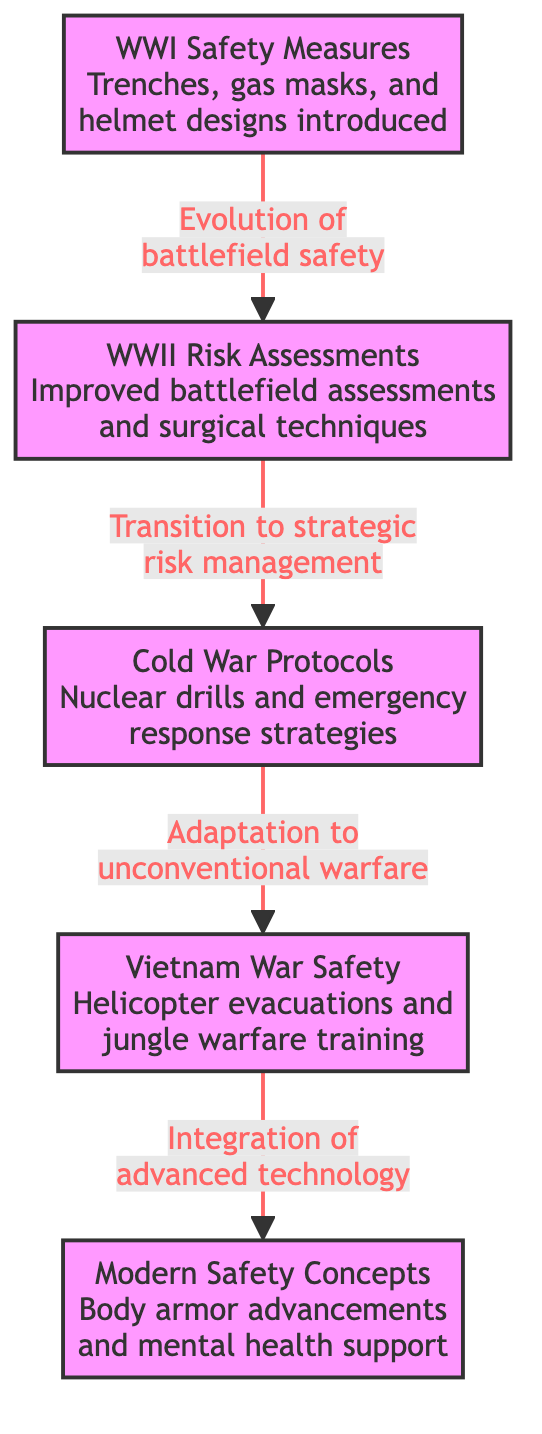What safety measures were introduced during WWI? The diagram states that trenches, gas masks, and helmet designs were introduced as safety measures for WWI. These are listed clearly in the WWI node.
Answer: Trenches, gas masks, and helmet designs What risk assessments were improved during WWII? From the diagram, it is indicated that improved battlefield assessments and surgical techniques were the focus during WWII as noted in the WWII node.
Answer: Improved battlefield assessments and surgical techniques How many conflict safety measures are represented in this diagram? By counting the nodes (WWI, WWII, Cold War, Vietnam War, Modern Safety Concepts) in the diagram, we find that there are a total of five distinct conflict safety measures outlined.
Answer: 5 What did Cold War protocols adapt to? The diagram shows that Cold War protocols involved adaptation to unconventional warfare, as represented in the edge leading to the Vietnam War node.
Answer: Unconventional warfare What evolution is illustrated from WWI to WWII? The diagram indicates that there is an evolution of battlefield safety from WWI to WWII, highlighting the developments that occurred as shown by the directed arrow between these nodes.
Answer: Evolution of battlefield safety What connects Vietnam War safety to modern concepts? The diagram shows a direct connection between the Vietnam War safety measures and modern safety concepts through the integration of advanced technology. This information can be found in the edge leading to the modern safety concepts node.
Answer: Integration of advanced technology What is a key feature of modern safety concepts? According to the diagram, a key feature of modern safety concepts includes advancements in body armor and mental health support, as stated in the MC node.
Answer: Body armor advancements and mental health support What type of diagram is this? The type of diagram presented is a flowchart, which outlines relationships and evolutionary steps among various safety protocols and risk assessments from the conflicts. This is evident from the structure of interconnected nodes and relationships.
Answer: Flowchart How are WWII risk assessments characterized? The diagram characterizes WWII risk assessments as an improvement in battlefield assessments and surgical techniques, linking them to enhanced safety measures. This is clearly indicated within the WWII node.
Answer: Improved battlefield assessments and surgical techniques 